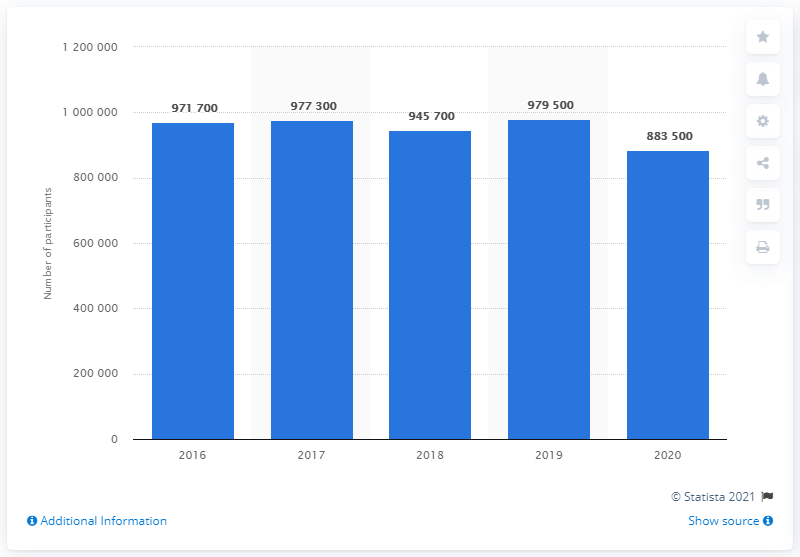Draw attention to some important aspects in this diagram. In the year 2019, there were approximately 979,500 people participating in golf in England. The number of people participating in golf in England between the years 2019 and 2020 showed a decrease of 96,000. 